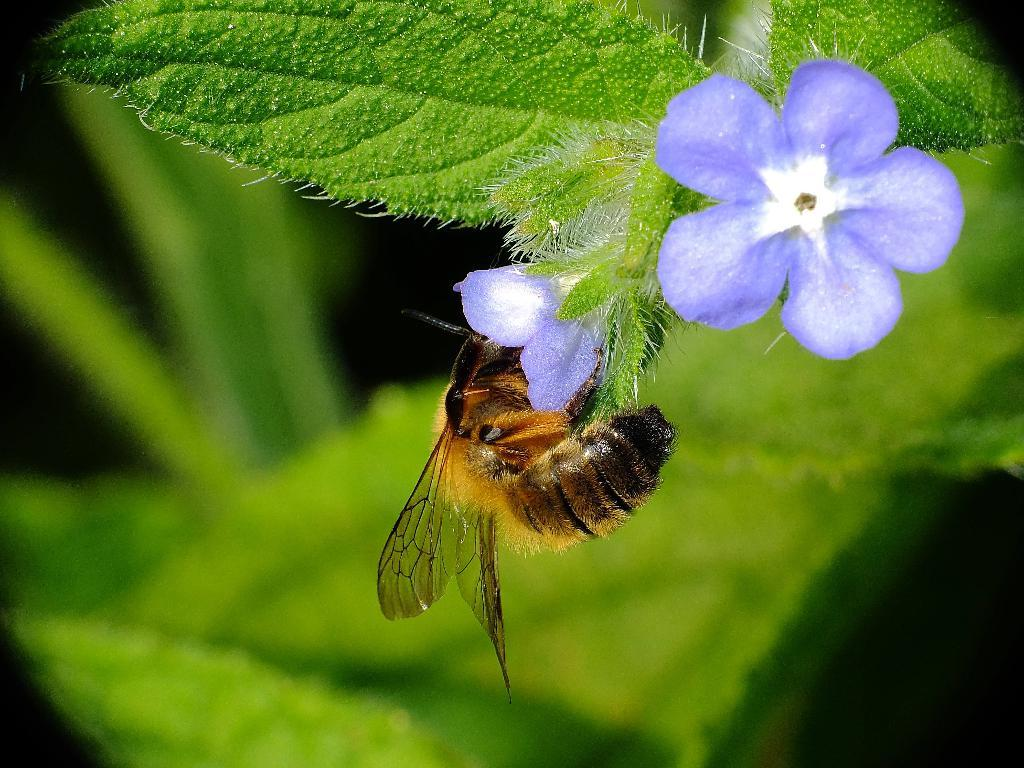What type of plant material can be seen in the image? There are leaves in the image. How many flowers are present in the image? There are two flowers in the image. What type of small animal or organism can be seen in the image? There is an insect in the image. Can you describe the background of the image? The background of the image is blurred. Where is the shelf located in the image? There is no shelf present in the image. What shape is the wren in the image? There is no wren present in the image. 